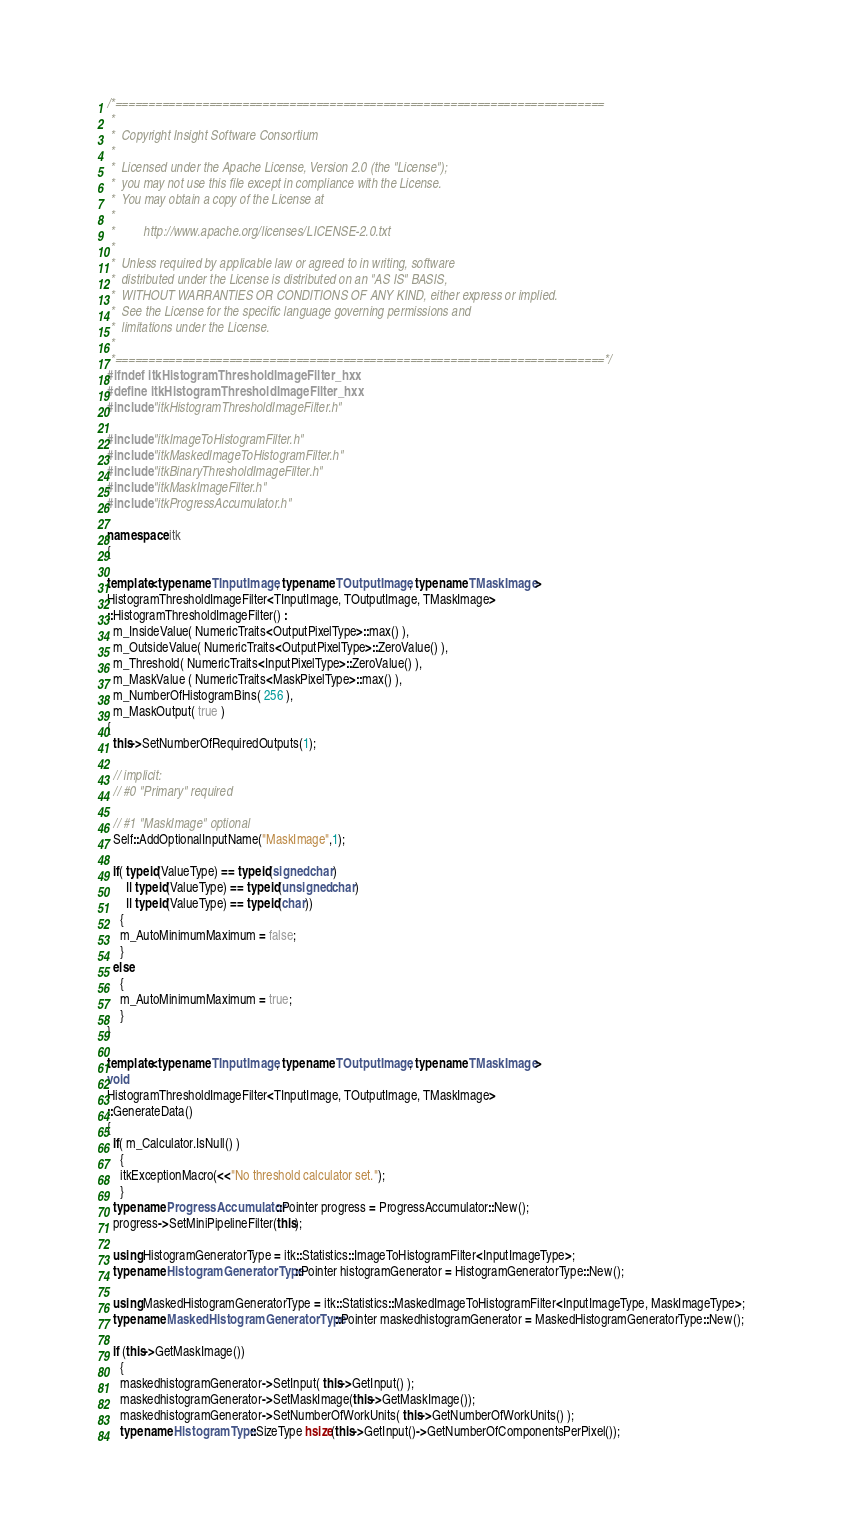<code> <loc_0><loc_0><loc_500><loc_500><_C++_>/*=========================================================================
 *
 *  Copyright Insight Software Consortium
 *
 *  Licensed under the Apache License, Version 2.0 (the "License");
 *  you may not use this file except in compliance with the License.
 *  You may obtain a copy of the License at
 *
 *         http://www.apache.org/licenses/LICENSE-2.0.txt
 *
 *  Unless required by applicable law or agreed to in writing, software
 *  distributed under the License is distributed on an "AS IS" BASIS,
 *  WITHOUT WARRANTIES OR CONDITIONS OF ANY KIND, either express or implied.
 *  See the License for the specific language governing permissions and
 *  limitations under the License.
 *
 *=========================================================================*/
#ifndef itkHistogramThresholdImageFilter_hxx
#define itkHistogramThresholdImageFilter_hxx
#include "itkHistogramThresholdImageFilter.h"

#include "itkImageToHistogramFilter.h"
#include "itkMaskedImageToHistogramFilter.h"
#include "itkBinaryThresholdImageFilter.h"
#include "itkMaskImageFilter.h"
#include "itkProgressAccumulator.h"

namespace itk
{

template<typename TInputImage, typename TOutputImage, typename TMaskImage>
HistogramThresholdImageFilter<TInputImage, TOutputImage, TMaskImage>
::HistogramThresholdImageFilter() :
  m_InsideValue( NumericTraits<OutputPixelType>::max() ),
  m_OutsideValue( NumericTraits<OutputPixelType>::ZeroValue() ),
  m_Threshold( NumericTraits<InputPixelType>::ZeroValue() ),
  m_MaskValue ( NumericTraits<MaskPixelType>::max() ),
  m_NumberOfHistogramBins( 256 ),
  m_MaskOutput( true )
{
  this->SetNumberOfRequiredOutputs(1);

  // implicit:
  // #0 "Primary" required

  // #1 "MaskImage" optional
  Self::AddOptionalInputName("MaskImage",1);

  if( typeid(ValueType) == typeid(signed char)
      || typeid(ValueType) == typeid(unsigned char)
      || typeid(ValueType) == typeid(char))
    {
    m_AutoMinimumMaximum = false;
    }
  else
    {
    m_AutoMinimumMaximum = true;
    }
}

template<typename TInputImage, typename TOutputImage, typename TMaskImage>
void
HistogramThresholdImageFilter<TInputImage, TOutputImage, TMaskImage>
::GenerateData()
{
  if( m_Calculator.IsNull() )
    {
    itkExceptionMacro(<<"No threshold calculator set.");
    }
  typename ProgressAccumulator::Pointer progress = ProgressAccumulator::New();
  progress->SetMiniPipelineFilter(this);

  using HistogramGeneratorType = itk::Statistics::ImageToHistogramFilter<InputImageType>;
  typename HistogramGeneratorType::Pointer histogramGenerator = HistogramGeneratorType::New();

  using MaskedHistogramGeneratorType = itk::Statistics::MaskedImageToHistogramFilter<InputImageType, MaskImageType>;
  typename MaskedHistogramGeneratorType::Pointer maskedhistogramGenerator = MaskedHistogramGeneratorType::New();

  if (this->GetMaskImage())
    {
    maskedhistogramGenerator->SetInput( this->GetInput() );
    maskedhistogramGenerator->SetMaskImage(this->GetMaskImage());
    maskedhistogramGenerator->SetNumberOfWorkUnits( this->GetNumberOfWorkUnits() );
    typename HistogramType::SizeType hsize(this->GetInput()->GetNumberOfComponentsPerPixel());</code> 